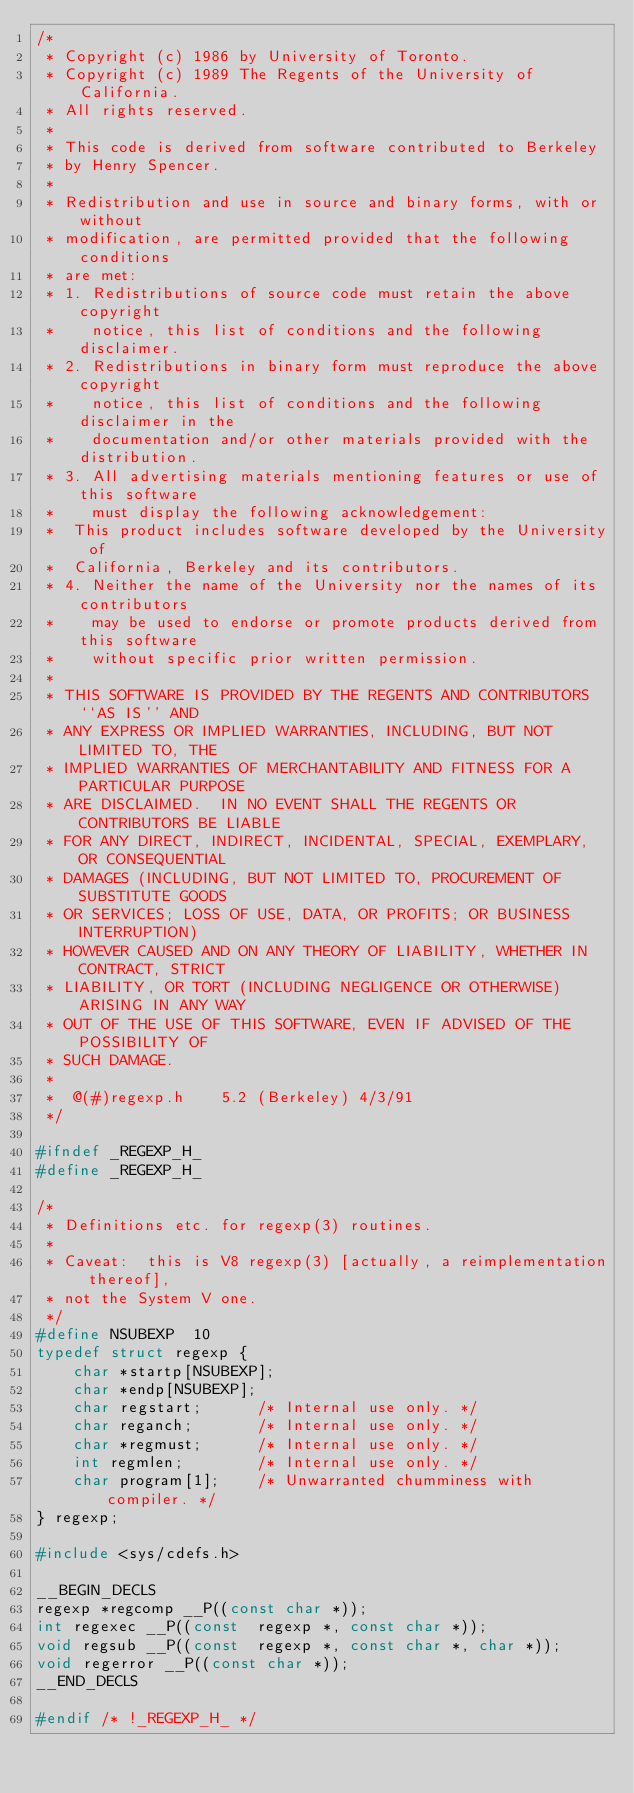Convert code to text. <code><loc_0><loc_0><loc_500><loc_500><_C_>/*
 * Copyright (c) 1986 by University of Toronto.
 * Copyright (c) 1989 The Regents of the University of California.
 * All rights reserved.
 *
 * This code is derived from software contributed to Berkeley
 * by Henry Spencer.
 *
 * Redistribution and use in source and binary forms, with or without
 * modification, are permitted provided that the following conditions
 * are met:
 * 1. Redistributions of source code must retain the above copyright
 *    notice, this list of conditions and the following disclaimer.
 * 2. Redistributions in binary form must reproduce the above copyright
 *    notice, this list of conditions and the following disclaimer in the
 *    documentation and/or other materials provided with the distribution.
 * 3. All advertising materials mentioning features or use of this software
 *    must display the following acknowledgement:
 *	This product includes software developed by the University of
 *	California, Berkeley and its contributors.
 * 4. Neither the name of the University nor the names of its contributors
 *    may be used to endorse or promote products derived from this software
 *    without specific prior written permission.
 *
 * THIS SOFTWARE IS PROVIDED BY THE REGENTS AND CONTRIBUTORS ``AS IS'' AND
 * ANY EXPRESS OR IMPLIED WARRANTIES, INCLUDING, BUT NOT LIMITED TO, THE
 * IMPLIED WARRANTIES OF MERCHANTABILITY AND FITNESS FOR A PARTICULAR PURPOSE
 * ARE DISCLAIMED.  IN NO EVENT SHALL THE REGENTS OR CONTRIBUTORS BE LIABLE
 * FOR ANY DIRECT, INDIRECT, INCIDENTAL, SPECIAL, EXEMPLARY, OR CONSEQUENTIAL
 * DAMAGES (INCLUDING, BUT NOT LIMITED TO, PROCUREMENT OF SUBSTITUTE GOODS
 * OR SERVICES; LOSS OF USE, DATA, OR PROFITS; OR BUSINESS INTERRUPTION)
 * HOWEVER CAUSED AND ON ANY THEORY OF LIABILITY, WHETHER IN CONTRACT, STRICT
 * LIABILITY, OR TORT (INCLUDING NEGLIGENCE OR OTHERWISE) ARISING IN ANY WAY
 * OUT OF THE USE OF THIS SOFTWARE, EVEN IF ADVISED OF THE POSSIBILITY OF
 * SUCH DAMAGE.
 *
 *	@(#)regexp.h	5.2 (Berkeley) 4/3/91
 */

#ifndef	_REGEXP_H_
#define	_REGEXP_H_

/*
 * Definitions etc. for regexp(3) routines.
 *
 * Caveat:  this is V8 regexp(3) [actually, a reimplementation thereof],
 * not the System V one.
 */
#define NSUBEXP  10
typedef struct regexp {
	char *startp[NSUBEXP];
	char *endp[NSUBEXP];
	char regstart;		/* Internal use only. */
	char reganch;		/* Internal use only. */
	char *regmust;		/* Internal use only. */
	int regmlen;		/* Internal use only. */
	char program[1];	/* Unwarranted chumminess with compiler. */
} regexp;

#include <sys/cdefs.h>

__BEGIN_DECLS
regexp *regcomp __P((const char *));
int regexec __P((const  regexp *, const char *));
void regsub __P((const  regexp *, const char *, char *));
void regerror __P((const char *));
__END_DECLS

#endif /* !_REGEXP_H_ */
</code> 